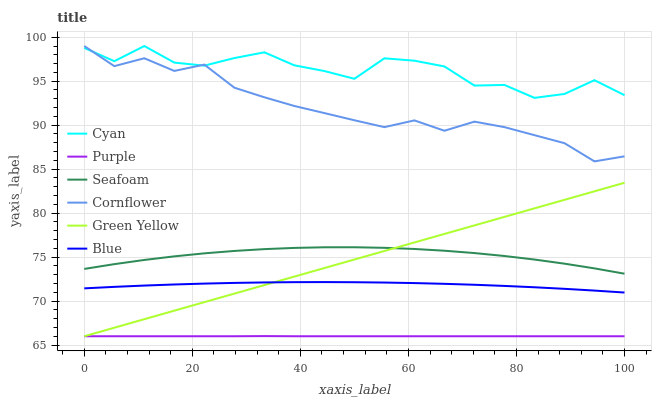Does Purple have the minimum area under the curve?
Answer yes or no. Yes. Does Cyan have the maximum area under the curve?
Answer yes or no. Yes. Does Cornflower have the minimum area under the curve?
Answer yes or no. No. Does Cornflower have the maximum area under the curve?
Answer yes or no. No. Is Green Yellow the smoothest?
Answer yes or no. Yes. Is Cyan the roughest?
Answer yes or no. Yes. Is Cornflower the smoothest?
Answer yes or no. No. Is Cornflower the roughest?
Answer yes or no. No. Does Cornflower have the lowest value?
Answer yes or no. No. Does Cyan have the highest value?
Answer yes or no. Yes. Does Purple have the highest value?
Answer yes or no. No. Is Seafoam less than Cyan?
Answer yes or no. Yes. Is Cyan greater than Blue?
Answer yes or no. Yes. Does Green Yellow intersect Purple?
Answer yes or no. Yes. Is Green Yellow less than Purple?
Answer yes or no. No. Is Green Yellow greater than Purple?
Answer yes or no. No. Does Seafoam intersect Cyan?
Answer yes or no. No. 